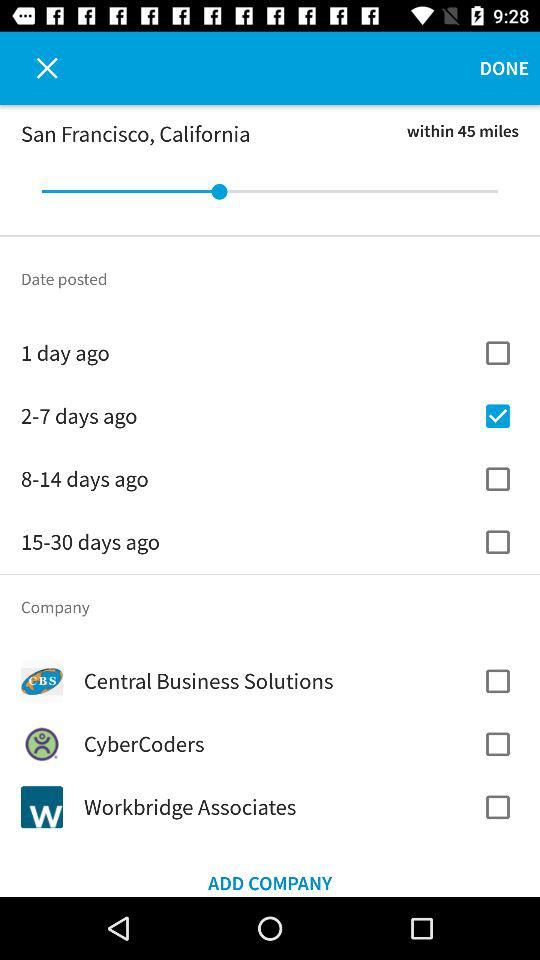Which option is checked in "Date posted"? The checked option is "2-7 days ago". 